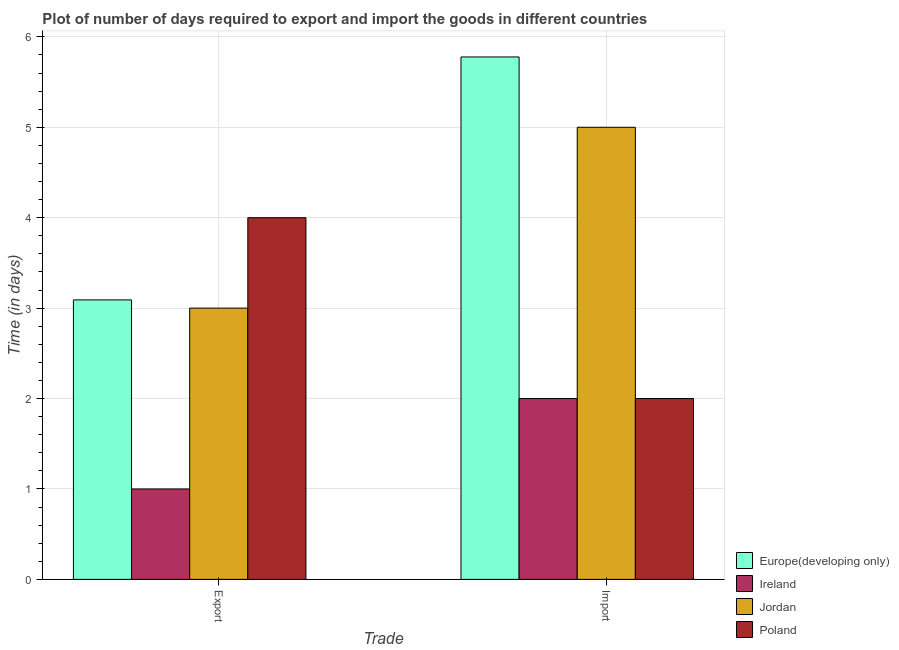How many groups of bars are there?
Make the answer very short. 2. Are the number of bars per tick equal to the number of legend labels?
Offer a terse response. Yes. What is the label of the 2nd group of bars from the left?
Provide a short and direct response. Import. What is the time required to export in Ireland?
Give a very brief answer. 1. Across all countries, what is the maximum time required to import?
Offer a terse response. 5.78. In which country was the time required to import maximum?
Offer a very short reply. Europe(developing only). In which country was the time required to import minimum?
Provide a short and direct response. Ireland. What is the total time required to export in the graph?
Provide a succinct answer. 11.09. What is the difference between the time required to export in Europe(developing only) and that in Jordan?
Provide a succinct answer. 0.09. What is the average time required to export per country?
Keep it short and to the point. 2.77. What is the difference between the time required to export and time required to import in Poland?
Make the answer very short. 2. Is the time required to import in Europe(developing only) less than that in Ireland?
Make the answer very short. No. What does the 2nd bar from the left in Export represents?
Keep it short and to the point. Ireland. What does the 4th bar from the right in Import represents?
Give a very brief answer. Europe(developing only). How many bars are there?
Your answer should be very brief. 8. Does the graph contain any zero values?
Offer a very short reply. No. Does the graph contain grids?
Provide a succinct answer. Yes. How are the legend labels stacked?
Provide a succinct answer. Vertical. What is the title of the graph?
Your response must be concise. Plot of number of days required to export and import the goods in different countries. Does "Dominica" appear as one of the legend labels in the graph?
Ensure brevity in your answer.  No. What is the label or title of the X-axis?
Provide a short and direct response. Trade. What is the label or title of the Y-axis?
Make the answer very short. Time (in days). What is the Time (in days) of Europe(developing only) in Export?
Offer a very short reply. 3.09. What is the Time (in days) of Ireland in Export?
Provide a short and direct response. 1. What is the Time (in days) in Europe(developing only) in Import?
Provide a succinct answer. 5.78. Across all Trade, what is the maximum Time (in days) of Europe(developing only)?
Your answer should be very brief. 5.78. Across all Trade, what is the minimum Time (in days) of Europe(developing only)?
Your answer should be compact. 3.09. Across all Trade, what is the minimum Time (in days) in Ireland?
Give a very brief answer. 1. Across all Trade, what is the minimum Time (in days) in Jordan?
Keep it short and to the point. 3. Across all Trade, what is the minimum Time (in days) in Poland?
Provide a short and direct response. 2. What is the total Time (in days) of Europe(developing only) in the graph?
Offer a very short reply. 8.87. What is the total Time (in days) in Ireland in the graph?
Your answer should be very brief. 3. What is the total Time (in days) in Jordan in the graph?
Provide a short and direct response. 8. What is the difference between the Time (in days) in Europe(developing only) in Export and that in Import?
Keep it short and to the point. -2.69. What is the difference between the Time (in days) of Jordan in Export and that in Import?
Your answer should be very brief. -2. What is the difference between the Time (in days) in Poland in Export and that in Import?
Ensure brevity in your answer.  2. What is the difference between the Time (in days) of Europe(developing only) in Export and the Time (in days) of Jordan in Import?
Provide a succinct answer. -1.91. What is the difference between the Time (in days) of Europe(developing only) in Export and the Time (in days) of Poland in Import?
Your answer should be very brief. 1.09. What is the difference between the Time (in days) of Ireland in Export and the Time (in days) of Jordan in Import?
Provide a short and direct response. -4. What is the difference between the Time (in days) in Ireland in Export and the Time (in days) in Poland in Import?
Provide a short and direct response. -1. What is the average Time (in days) in Europe(developing only) per Trade?
Provide a short and direct response. 4.43. What is the average Time (in days) of Jordan per Trade?
Your response must be concise. 4. What is the difference between the Time (in days) in Europe(developing only) and Time (in days) in Ireland in Export?
Your answer should be very brief. 2.09. What is the difference between the Time (in days) in Europe(developing only) and Time (in days) in Jordan in Export?
Keep it short and to the point. 0.09. What is the difference between the Time (in days) in Europe(developing only) and Time (in days) in Poland in Export?
Your response must be concise. -0.91. What is the difference between the Time (in days) in Europe(developing only) and Time (in days) in Ireland in Import?
Give a very brief answer. 3.78. What is the difference between the Time (in days) in Europe(developing only) and Time (in days) in Jordan in Import?
Provide a short and direct response. 0.78. What is the difference between the Time (in days) in Europe(developing only) and Time (in days) in Poland in Import?
Give a very brief answer. 3.78. What is the difference between the Time (in days) of Ireland and Time (in days) of Jordan in Import?
Make the answer very short. -3. What is the difference between the Time (in days) in Jordan and Time (in days) in Poland in Import?
Offer a terse response. 3. What is the ratio of the Time (in days) in Europe(developing only) in Export to that in Import?
Provide a short and direct response. 0.54. What is the ratio of the Time (in days) of Ireland in Export to that in Import?
Your answer should be compact. 0.5. What is the ratio of the Time (in days) in Poland in Export to that in Import?
Make the answer very short. 2. What is the difference between the highest and the second highest Time (in days) in Europe(developing only)?
Make the answer very short. 2.69. What is the difference between the highest and the second highest Time (in days) of Jordan?
Provide a short and direct response. 2. What is the difference between the highest and the lowest Time (in days) in Europe(developing only)?
Make the answer very short. 2.69. What is the difference between the highest and the lowest Time (in days) in Ireland?
Give a very brief answer. 1. What is the difference between the highest and the lowest Time (in days) in Jordan?
Your response must be concise. 2. What is the difference between the highest and the lowest Time (in days) of Poland?
Give a very brief answer. 2. 